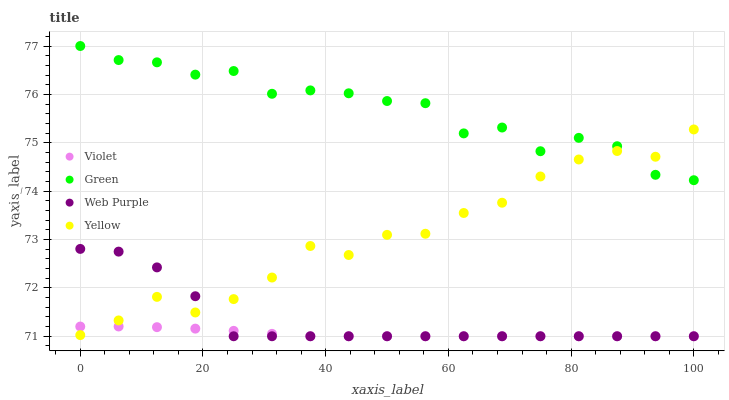Does Violet have the minimum area under the curve?
Answer yes or no. Yes. Does Green have the maximum area under the curve?
Answer yes or no. Yes. Does Yellow have the minimum area under the curve?
Answer yes or no. No. Does Yellow have the maximum area under the curve?
Answer yes or no. No. Is Violet the smoothest?
Answer yes or no. Yes. Is Green the roughest?
Answer yes or no. Yes. Is Yellow the smoothest?
Answer yes or no. No. Is Yellow the roughest?
Answer yes or no. No. Does Web Purple have the lowest value?
Answer yes or no. Yes. Does Yellow have the lowest value?
Answer yes or no. No. Does Green have the highest value?
Answer yes or no. Yes. Does Yellow have the highest value?
Answer yes or no. No. Is Violet less than Green?
Answer yes or no. Yes. Is Green greater than Violet?
Answer yes or no. Yes. Does Web Purple intersect Yellow?
Answer yes or no. Yes. Is Web Purple less than Yellow?
Answer yes or no. No. Is Web Purple greater than Yellow?
Answer yes or no. No. Does Violet intersect Green?
Answer yes or no. No. 